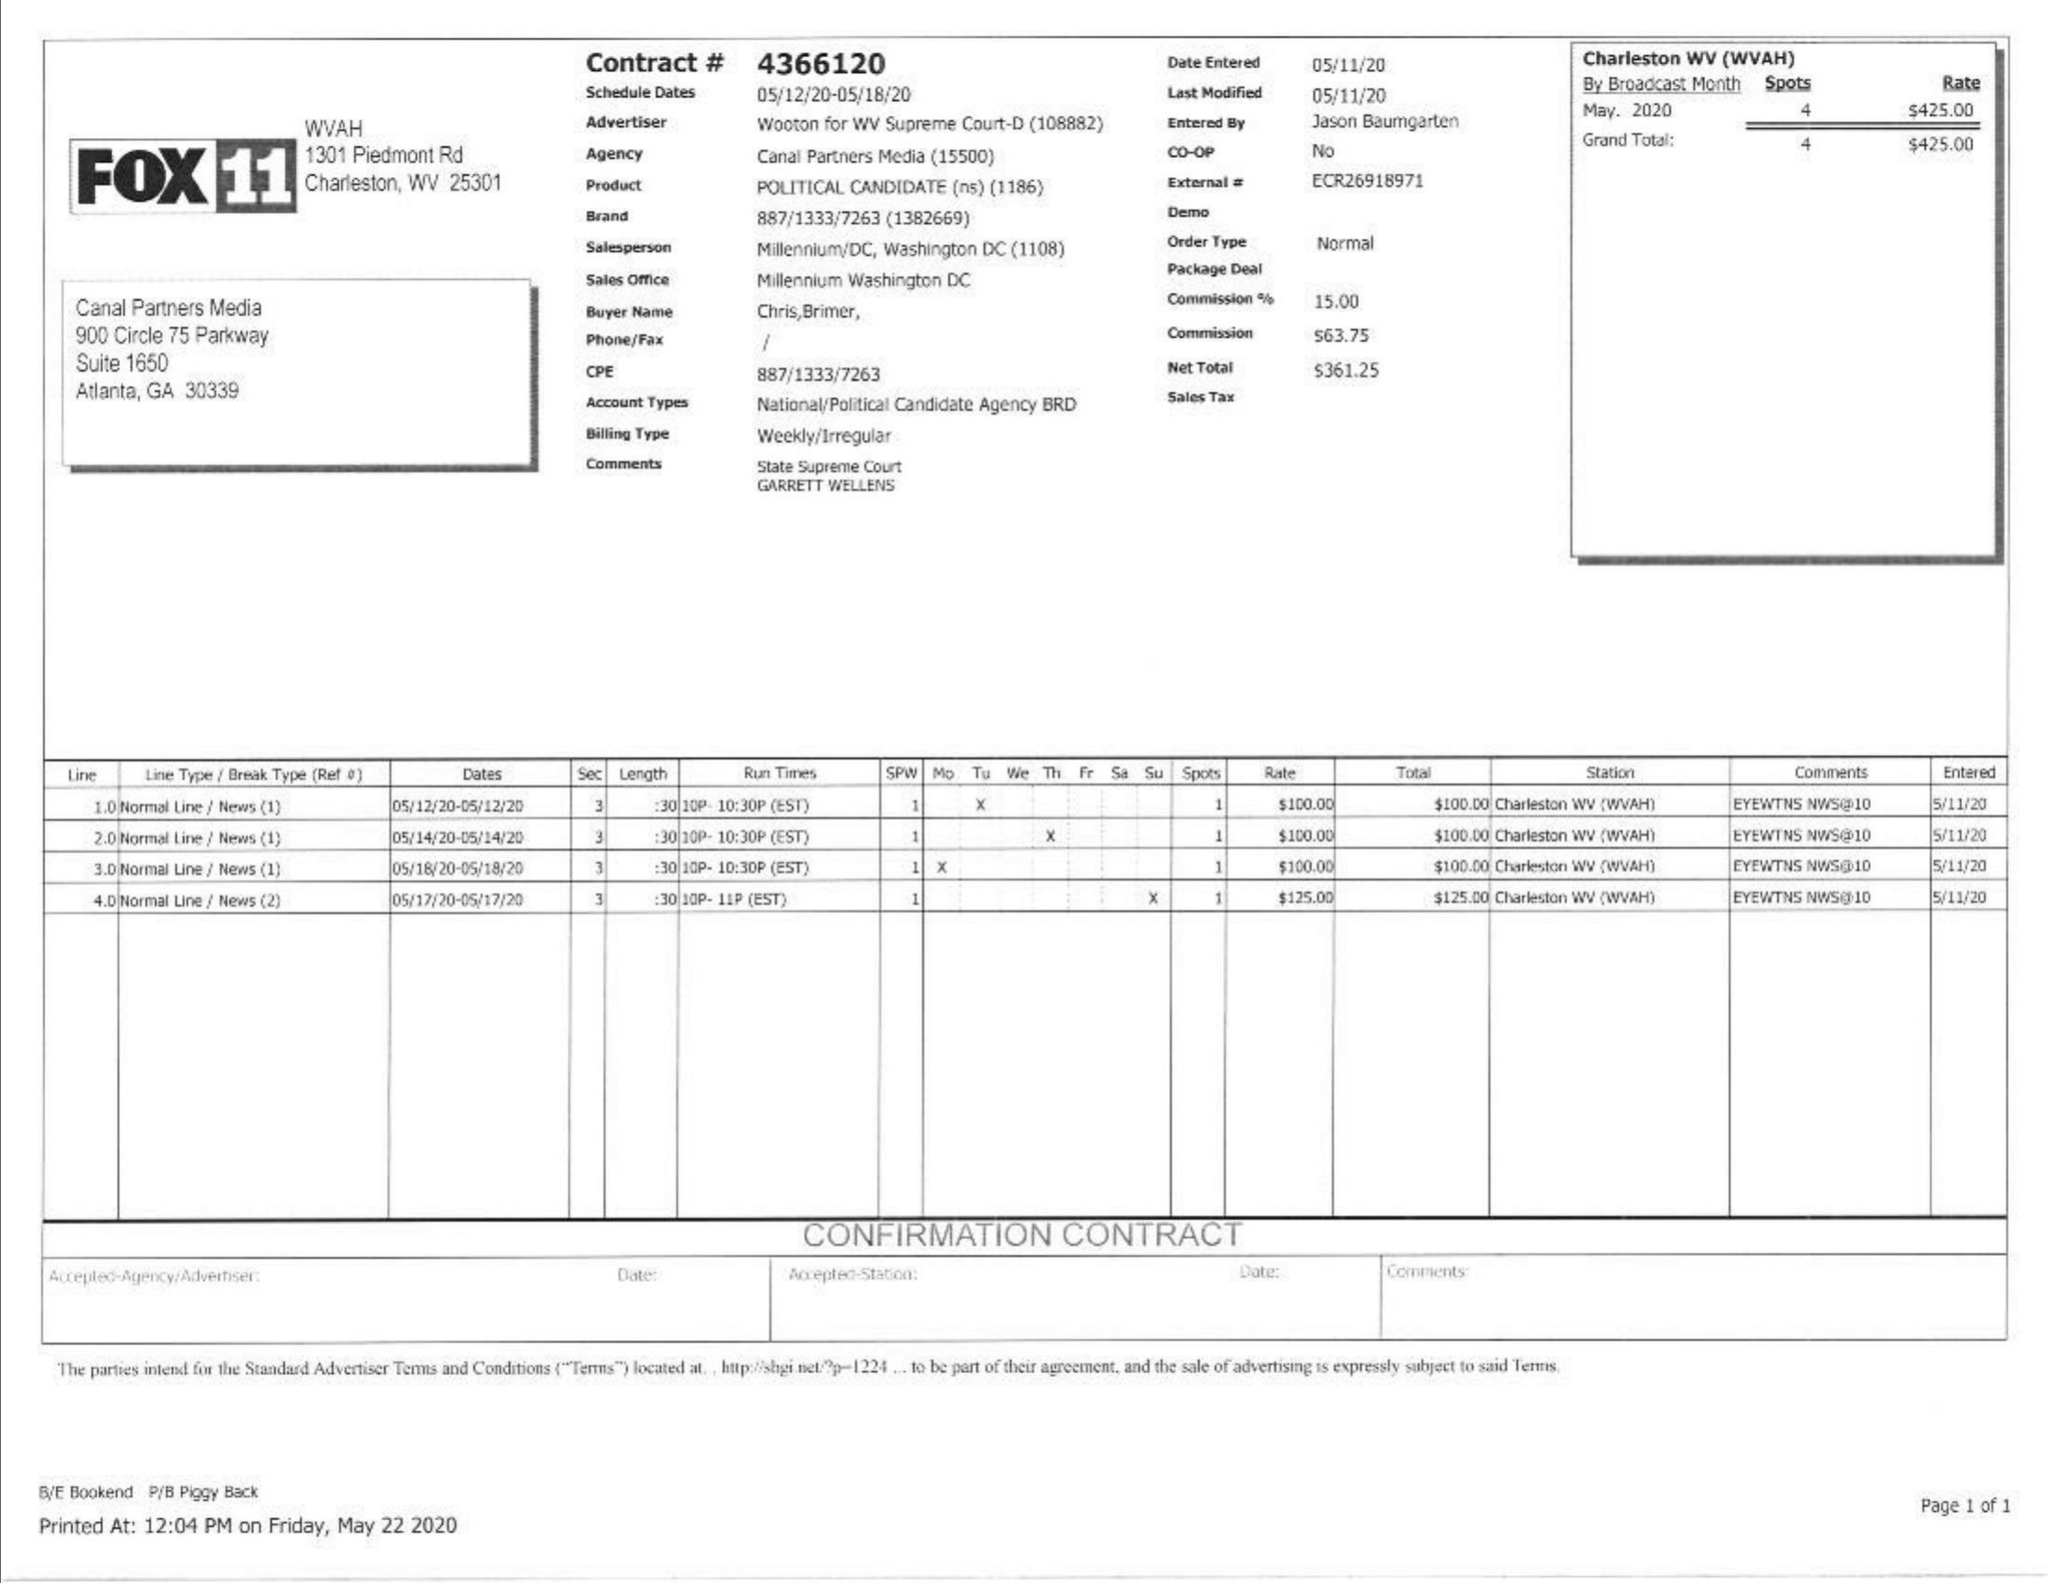What is the value for the gross_amount?
Answer the question using a single word or phrase. 425.00 